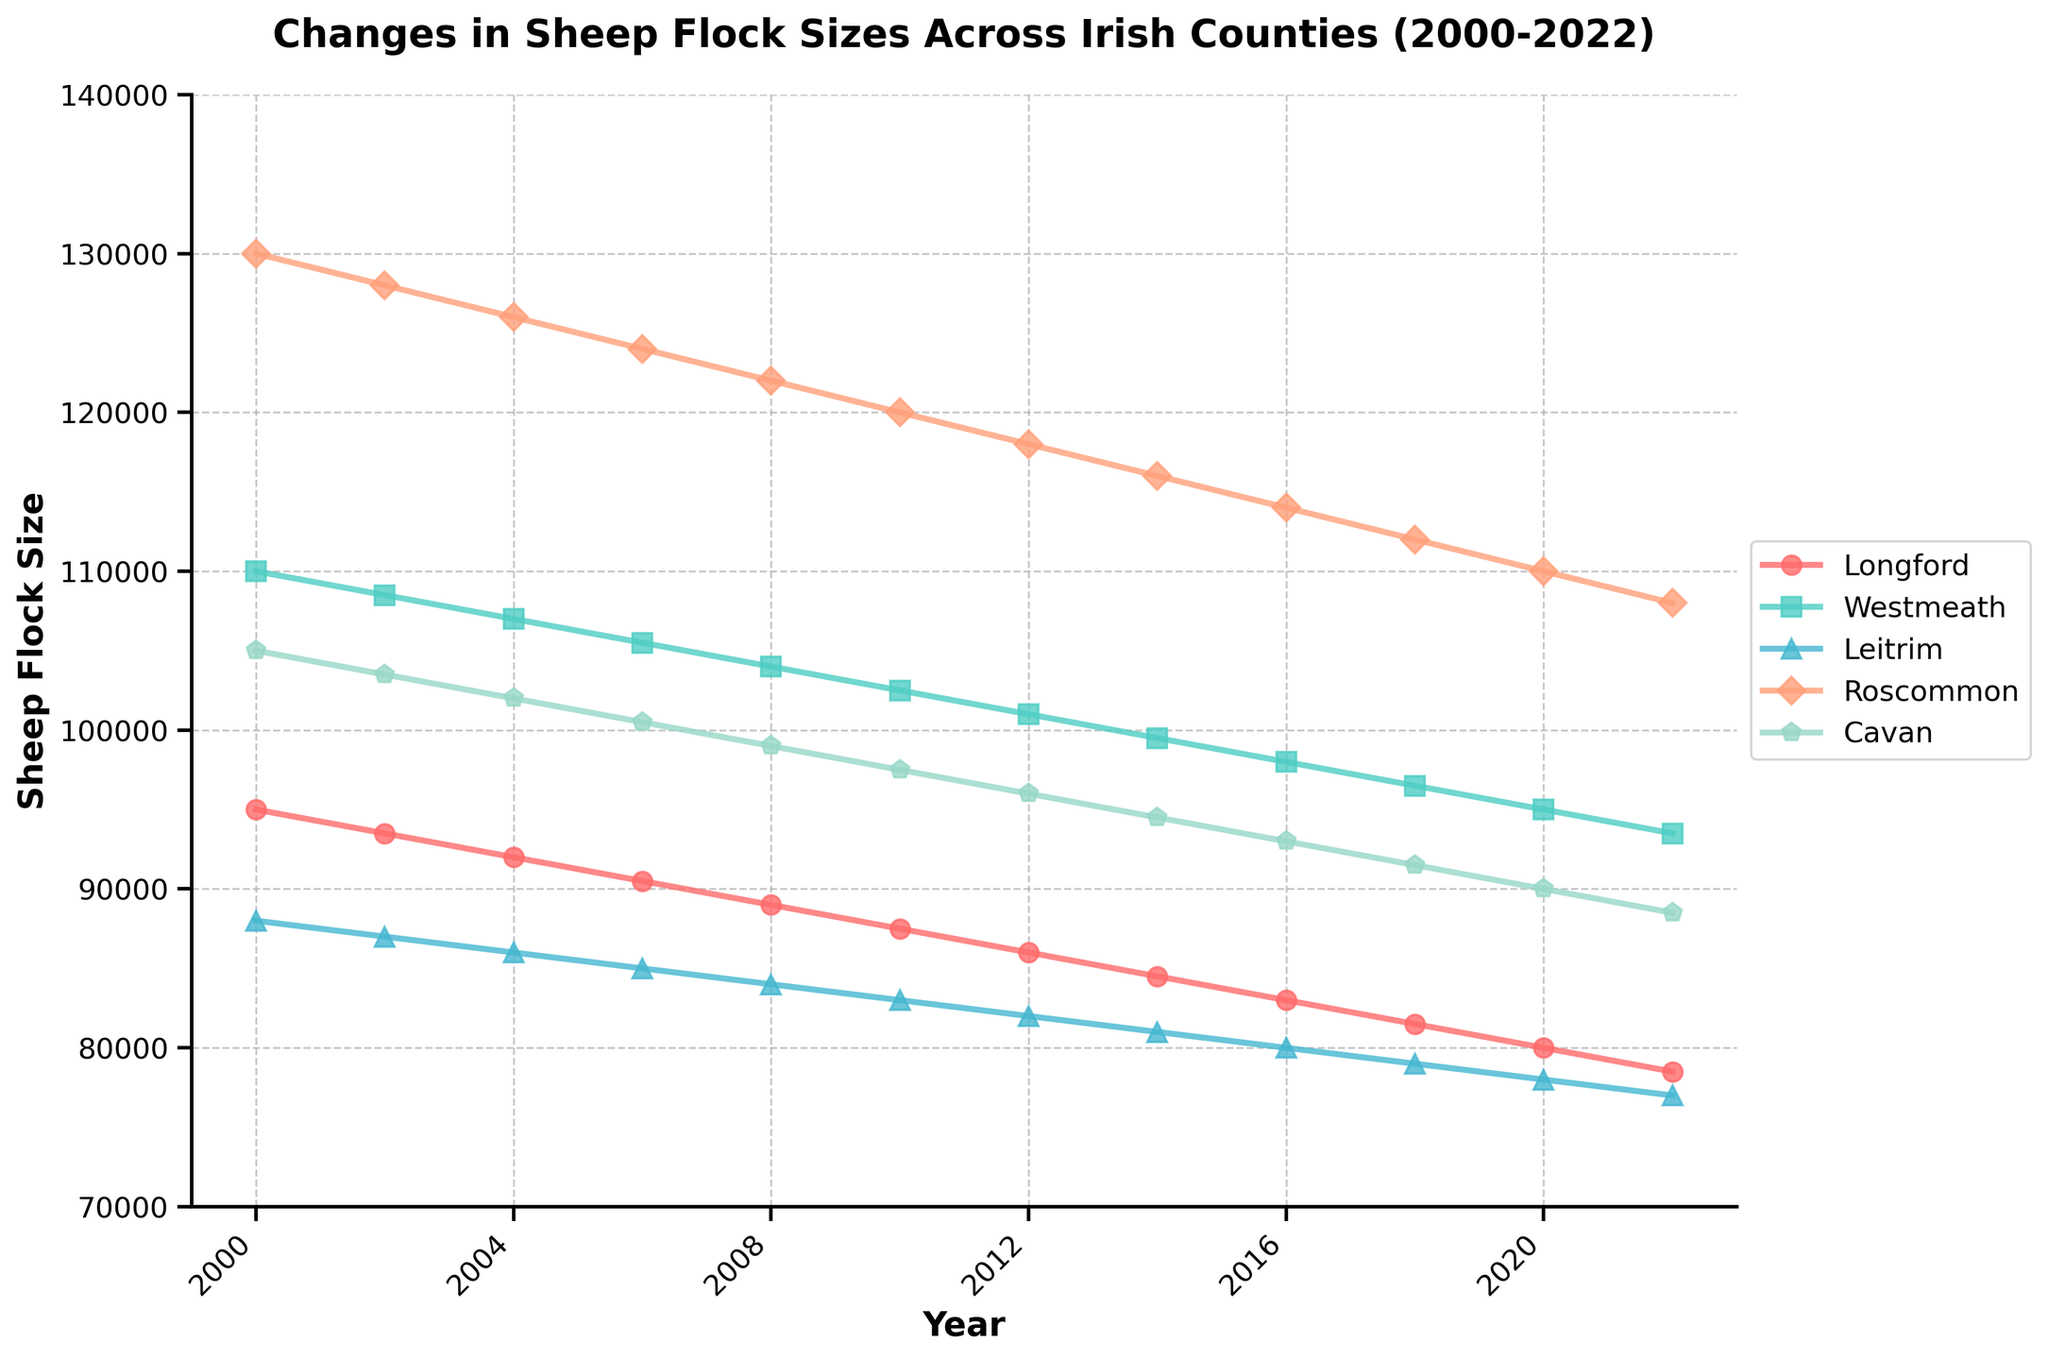Which county had the largest sheep flock size in 2000? To determine the county with the largest sheep flock size in 2000, look at the values for each county in the year 2000. The values are Longford (95,000), Westmeath (110,000), Leitrim (88,000), Roscommon (130,000), and Cavan (105,000). Roscommon has the largest number at 130,000.
Answer: Roscommon How much did the sheep flock size in Longford decrease from 2000 to 2022? Look at the values for Longford in 2000 and 2022. In 2000, Longford had 95,000 sheep, and in 2022, it had 78,500. Subtract the 2022 value from the 2000 value: 95,000 - 78,500 = 16,500.
Answer: 16,500 Which county saw the smallest reduction in sheep flock size from 2000 to 2022? Calculate the difference in flock sizes between 2000 and 2022 for each county. The differences are: Longford (16,500), Westmeath (16,500), Leitrim (11,000), Roscommon (22,000), and Cavan (16,500). Leitrim has the smallest reduction at 11,000.
Answer: Leitrim Rank the counties by sheep flock size in 2012 from highest to lowest. Check the values for each county in 2012: Longford (86,000), Westmeath (101,000), Leitrim (82,000), Roscommon (118,000), and Cavan (96,000). Rank them in descending order: Roscommon (118,000), Westmeath (101,000), Cavan (96,000), Longford (86,000), and Leitrim (82,000).
Answer: Roscommon, Westmeath, Cavan, Longford, Leitrim Which county had the steepest decline in sheep flock size from 2000 to 2002? Calculate the decline for each county between 2000 and 2002. The declines are: Longford (1,500), Westmeath (1,500), Leitrim (1,000), Roscommon (2,000), and Cavan (1,500). Roscommon had the steepest decline of 2,000.
Answer: Roscommon What was the average sheep flock size across all counties in 2008? Sum the flock sizes for all counties in 2008 and divide by the number of counties: (89,000 + 104,000 + 84,000 + 122,000 + 99,000) / 5 = 99,600.
Answer: 99,600 Compare the trend of sheep flock sizes in Westmeath and Roscommon from 2010 to 2022. Look at the values for Westmeath and Roscommon for each year from 2010 to 2022. Westmeath's trend is: 102,500 -> 101,000 -> 99,500 -> 98,000 -> 96,500 -> 95,000 -> 93,500. Roscommon's trend is: 120,000 -> 118,000 -> 116,000 -> 114,000 -> 112,000 -> 110,000 -> 108,000. Both counties show a decreasing trend, but Roscommon consistently has higher flock sizes.
Answer: Both decreased, Roscommon higher Which county maintained a stable decline in sheep flock size over the period? Examine each county's change over the years. Roscommon shows a consistent decline every two years without significant fluctuations.
Answer: Roscommon How much did the sheep flock size in Cavan change from 2002 to 2018? Look at the flock size for Cavan in 2002 and 2018. In 2002, it had 103,500, and in 2018, it had 91,500. Subtract the 2018 value from the 2002 value: 103,500 - 91,500 = 12,000.
Answer: 12,000 Which county had the second-largest sheep flock size in 2020? Check the values for each county in 2020. The values are Longford (80,000), Westmeath (95,000), Leitrim (78,000), Roscommon (110,000), and Cavan (90,000). The second-largest is Westmeath with 95,000.
Answer: Westmeath 